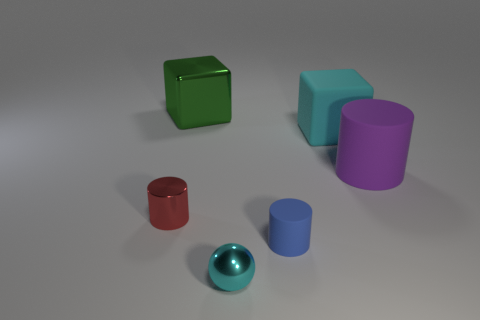Add 2 gray shiny balls. How many objects exist? 8 Subtract all spheres. How many objects are left? 5 Add 5 red matte blocks. How many red matte blocks exist? 5 Subtract 0 gray balls. How many objects are left? 6 Subtract all tiny shiny things. Subtract all small blue objects. How many objects are left? 3 Add 5 small shiny balls. How many small shiny balls are left? 6 